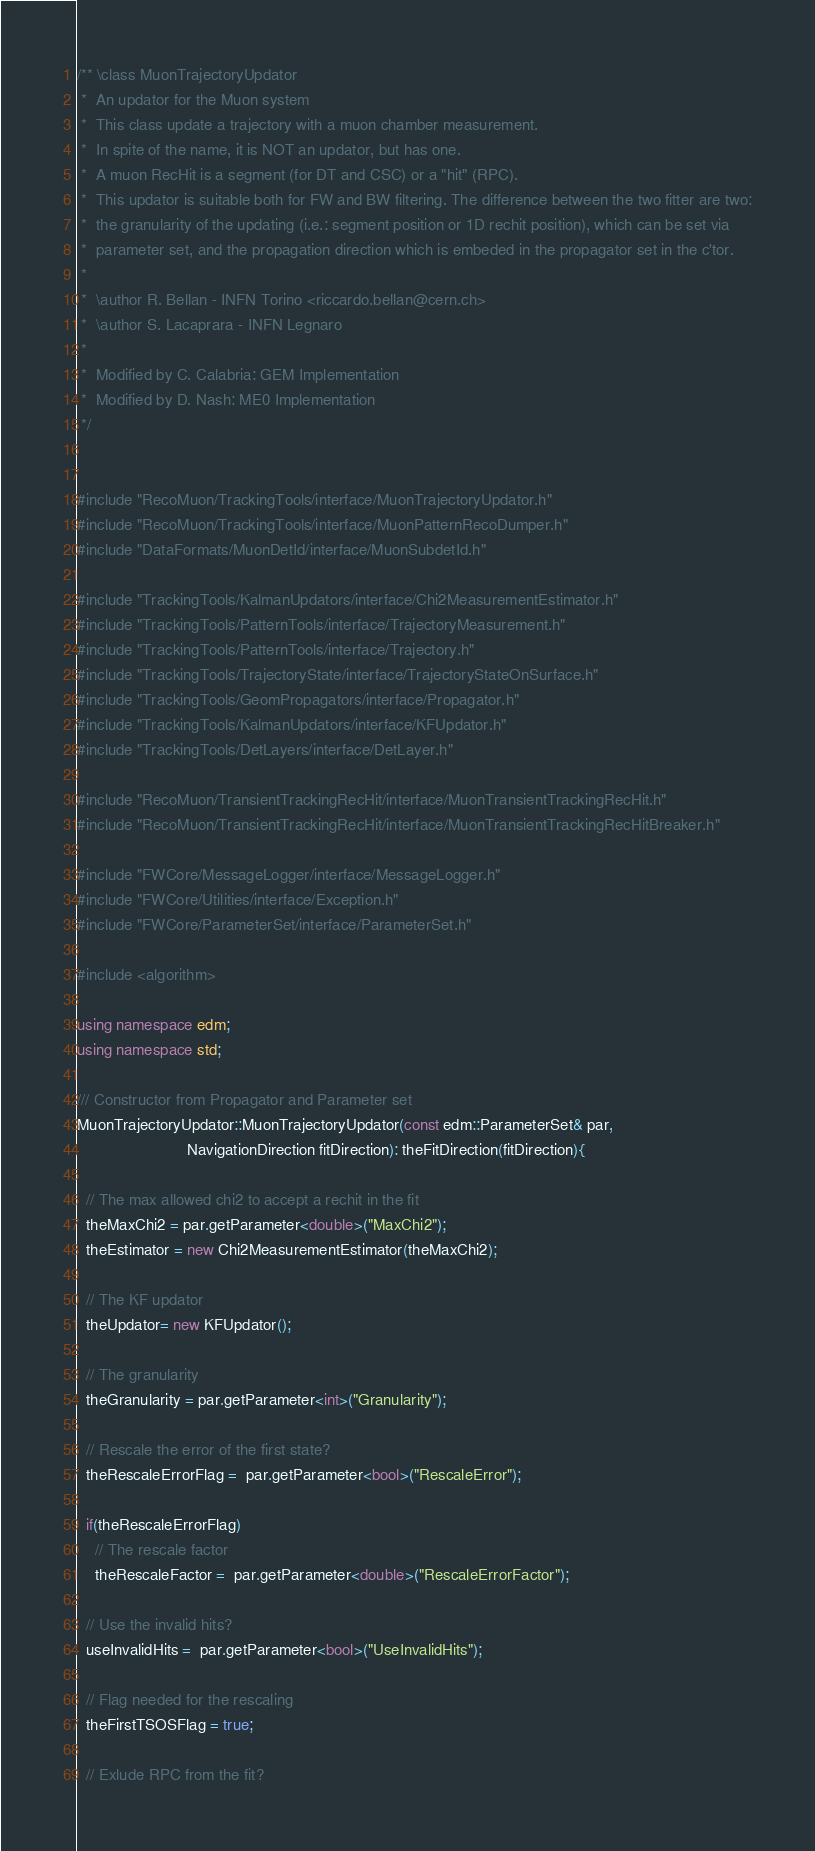Convert code to text. <code><loc_0><loc_0><loc_500><loc_500><_C++_>/** \class MuonTrajectoryUpdator
 *  An updator for the Muon system
 *  This class update a trajectory with a muon chamber measurement.
 *  In spite of the name, it is NOT an updator, but has one.
 *  A muon RecHit is a segment (for DT and CSC) or a "hit" (RPC).
 *  This updator is suitable both for FW and BW filtering. The difference between the two fitter are two:
 *  the granularity of the updating (i.e.: segment position or 1D rechit position), which can be set via
 *  parameter set, and the propagation direction which is embeded in the propagator set in the c'tor.
 *
 *  \author R. Bellan - INFN Torino <riccardo.bellan@cern.ch>
 *  \author S. Lacaprara - INFN Legnaro
 *
 *  Modified by C. Calabria: GEM Implementation
 *  Modified by D. Nash: ME0 Implementation
 */


#include "RecoMuon/TrackingTools/interface/MuonTrajectoryUpdator.h"
#include "RecoMuon/TrackingTools/interface/MuonPatternRecoDumper.h"
#include "DataFormats/MuonDetId/interface/MuonSubdetId.h"

#include "TrackingTools/KalmanUpdators/interface/Chi2MeasurementEstimator.h"
#include "TrackingTools/PatternTools/interface/TrajectoryMeasurement.h"
#include "TrackingTools/PatternTools/interface/Trajectory.h"
#include "TrackingTools/TrajectoryState/interface/TrajectoryStateOnSurface.h"
#include "TrackingTools/GeomPropagators/interface/Propagator.h"
#include "TrackingTools/KalmanUpdators/interface/KFUpdator.h"
#include "TrackingTools/DetLayers/interface/DetLayer.h"

#include "RecoMuon/TransientTrackingRecHit/interface/MuonTransientTrackingRecHit.h"
#include "RecoMuon/TransientTrackingRecHit/interface/MuonTransientTrackingRecHitBreaker.h"

#include "FWCore/MessageLogger/interface/MessageLogger.h"
#include "FWCore/Utilities/interface/Exception.h"
#include "FWCore/ParameterSet/interface/ParameterSet.h"

#include <algorithm>

using namespace edm;
using namespace std;

/// Constructor from Propagator and Parameter set
MuonTrajectoryUpdator::MuonTrajectoryUpdator(const edm::ParameterSet& par,
					     NavigationDirection fitDirection): theFitDirection(fitDirection){
  
  // The max allowed chi2 to accept a rechit in the fit
  theMaxChi2 = par.getParameter<double>("MaxChi2");
  theEstimator = new Chi2MeasurementEstimator(theMaxChi2);
  
  // The KF updator
  theUpdator= new KFUpdator();

  // The granularity
  theGranularity = par.getParameter<int>("Granularity");

  // Rescale the error of the first state?
  theRescaleErrorFlag =  par.getParameter<bool>("RescaleError");

  if(theRescaleErrorFlag)
    // The rescale factor
    theRescaleFactor =  par.getParameter<double>("RescaleErrorFactor");
  
  // Use the invalid hits?
  useInvalidHits =  par.getParameter<bool>("UseInvalidHits");

  // Flag needed for the rescaling
  theFirstTSOSFlag = true;

  // Exlude RPC from the fit?</code> 